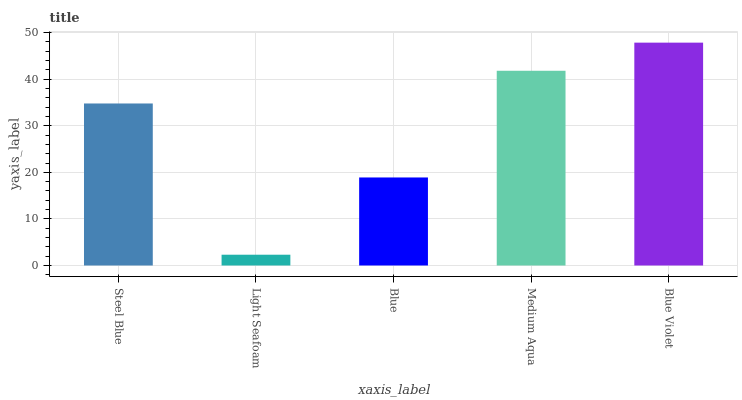Is Light Seafoam the minimum?
Answer yes or no. Yes. Is Blue Violet the maximum?
Answer yes or no. Yes. Is Blue the minimum?
Answer yes or no. No. Is Blue the maximum?
Answer yes or no. No. Is Blue greater than Light Seafoam?
Answer yes or no. Yes. Is Light Seafoam less than Blue?
Answer yes or no. Yes. Is Light Seafoam greater than Blue?
Answer yes or no. No. Is Blue less than Light Seafoam?
Answer yes or no. No. Is Steel Blue the high median?
Answer yes or no. Yes. Is Steel Blue the low median?
Answer yes or no. Yes. Is Light Seafoam the high median?
Answer yes or no. No. Is Blue Violet the low median?
Answer yes or no. No. 